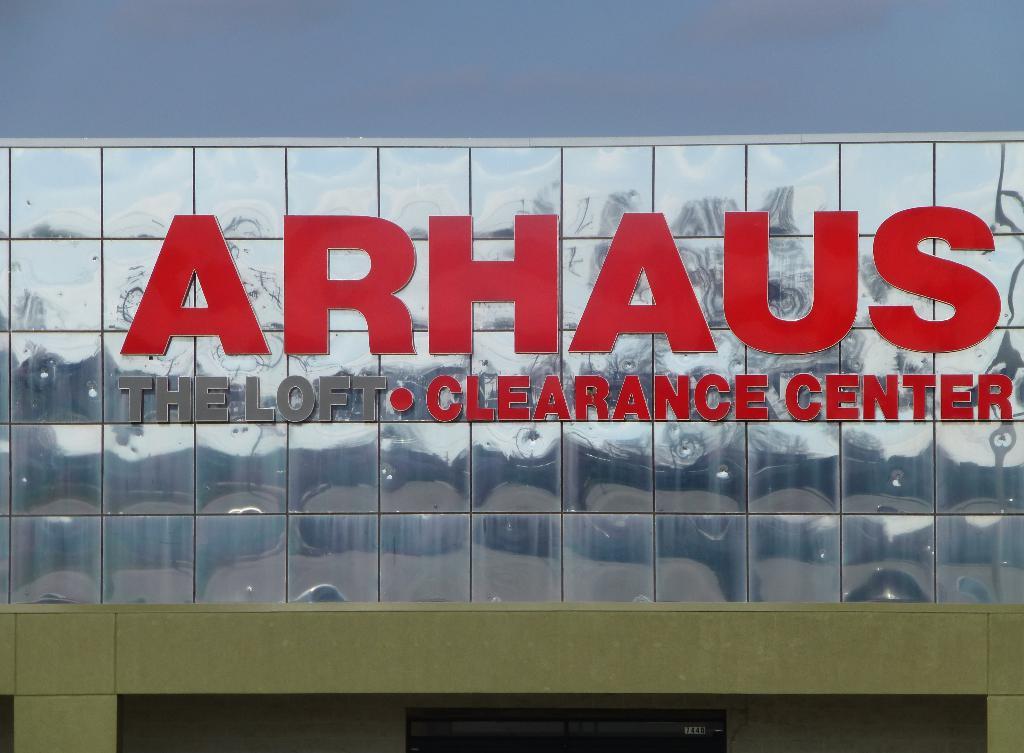What kind of center is this?
Your response must be concise. Clearance. What is the name of this store?
Your answer should be very brief. Arhaus. 